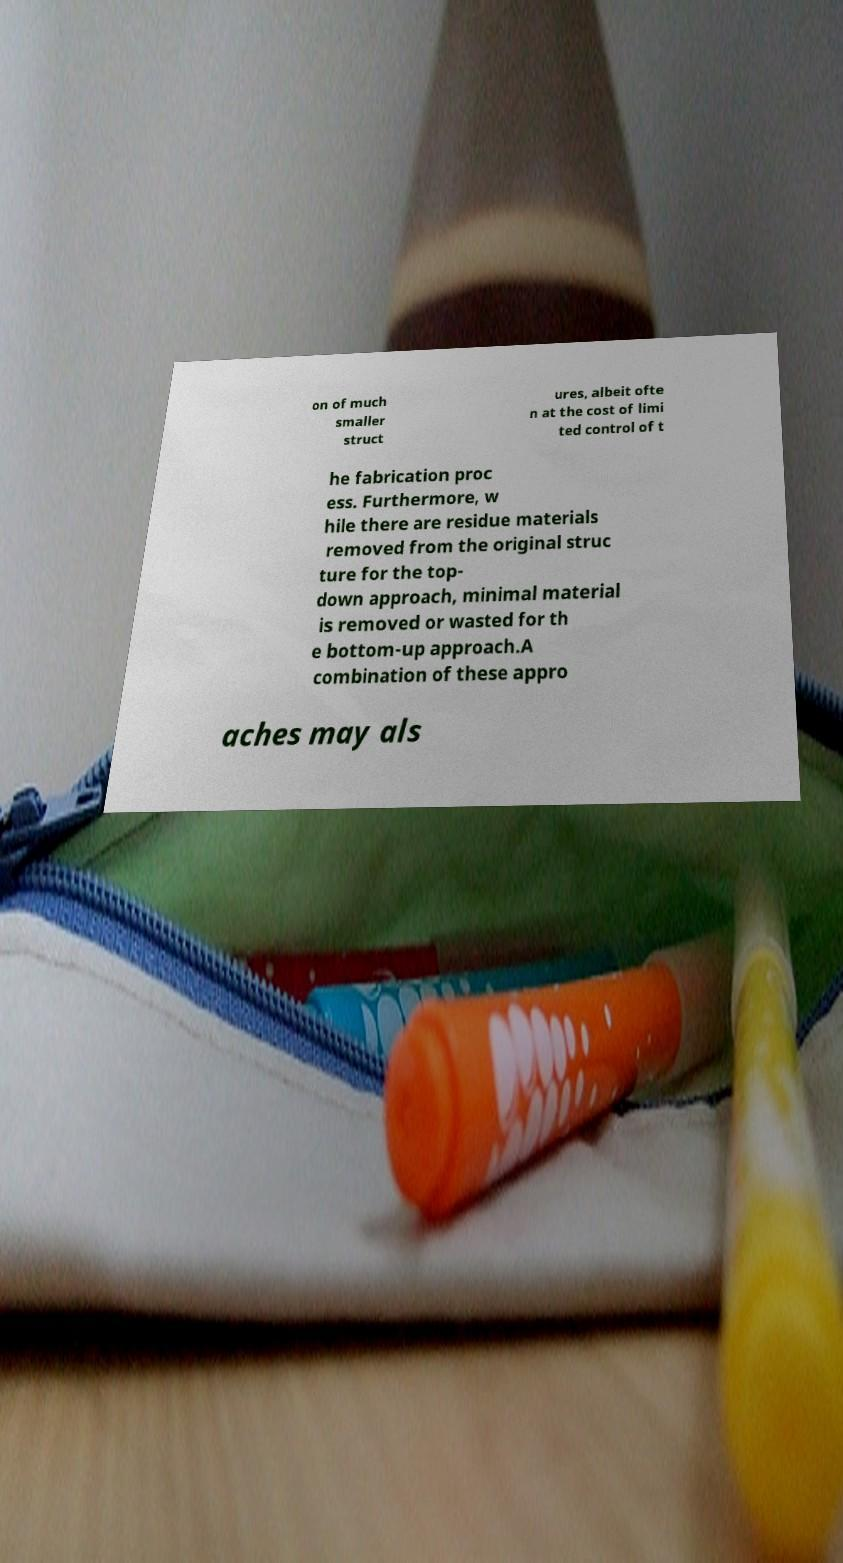Please identify and transcribe the text found in this image. on of much smaller struct ures, albeit ofte n at the cost of limi ted control of t he fabrication proc ess. Furthermore, w hile there are residue materials removed from the original struc ture for the top- down approach, minimal material is removed or wasted for th e bottom-up approach.A combination of these appro aches may als 